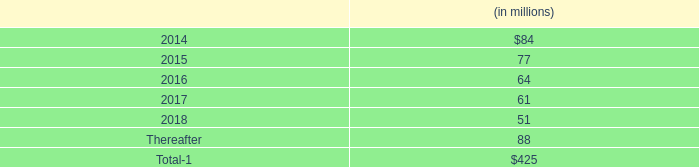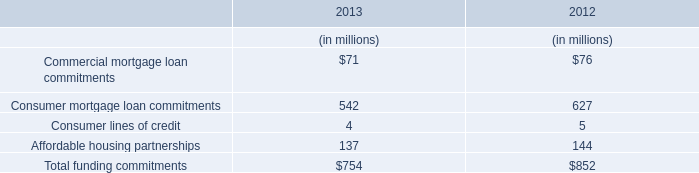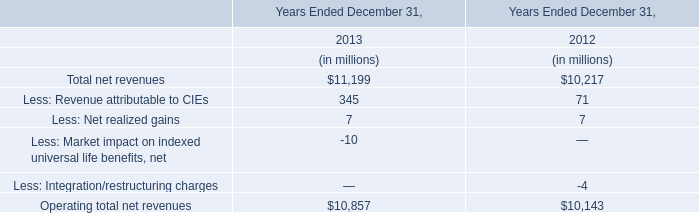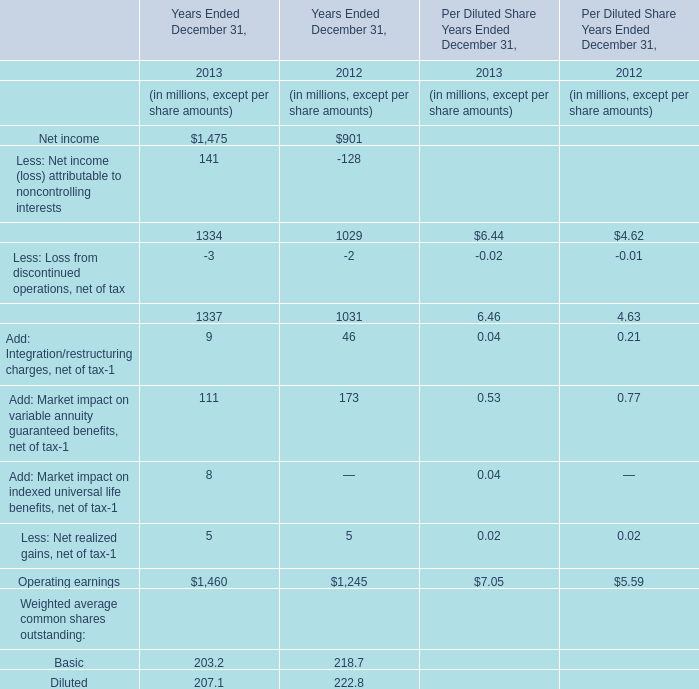What is the proportion of Net income attributable to Ameriprise Financial to the total in 2013? 
Computations: (1334 / 1475)
Answer: 0.90441. 